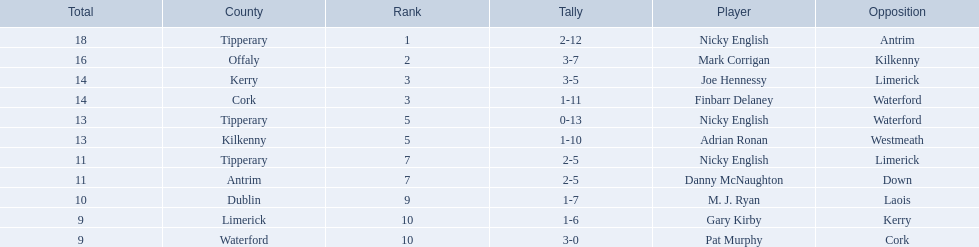What numbers are in the total column? 18, 16, 14, 14, 13, 13, 11, 11, 10, 9, 9. What row has the number 10 in the total column? 9, M. J. Ryan, Dublin, 1-7, 10, Laois. What name is in the player column for this row? M. J. Ryan. 